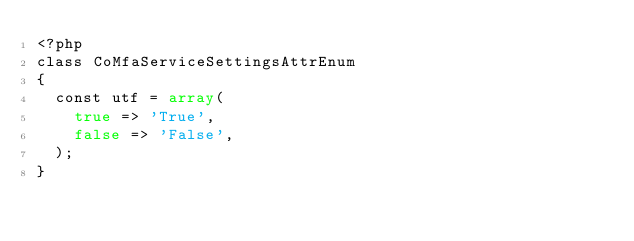<code> <loc_0><loc_0><loc_500><loc_500><_PHP_><?php
class CoMfaServiceSettingsAttrEnum
{
  const utf = array(
    true => 'True',
    false => 'False',
  );
}</code> 